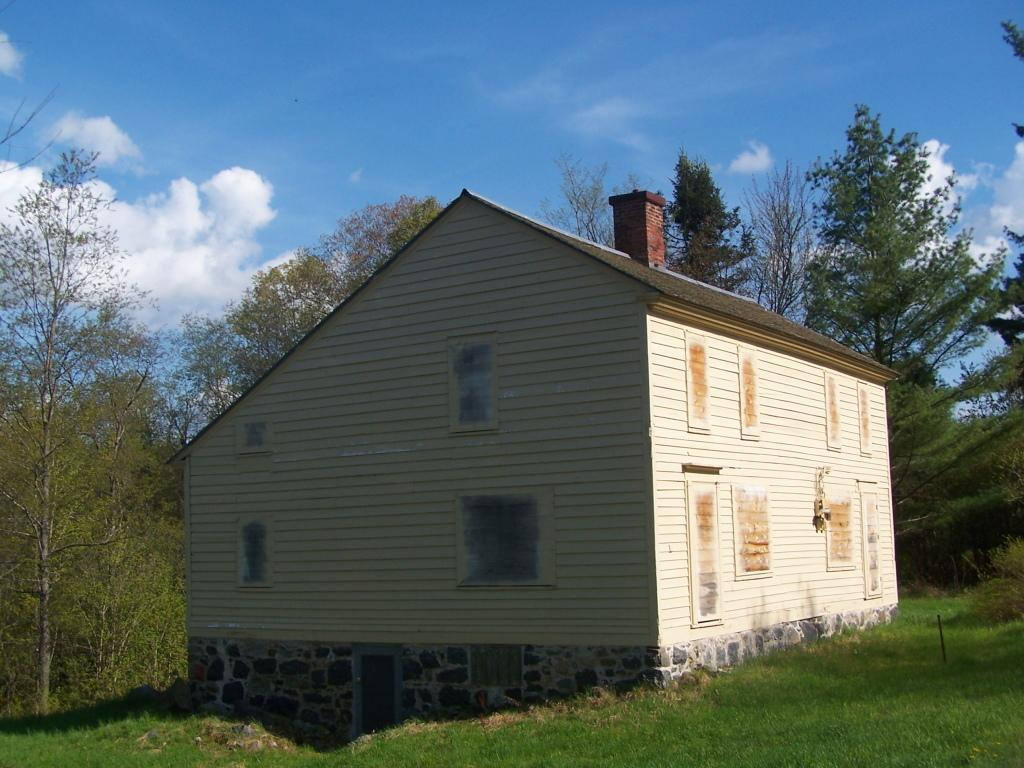What type of structure is in the image? There is a building (hurt) in the image. What feature can be seen on the building? The building has windows. What color is the building? The building is in cream color. What can be seen in the background of the image? There are trees, clouds, and a blue sky in the background of the image. What type of amusement can be seen in the image? There is no amusement present in the image; it features a building with windows and a cream color. What time of day is it in the image, considering the afternoon? The time of day cannot be determined from the image, as there are no specific clues or indicators of the time. 